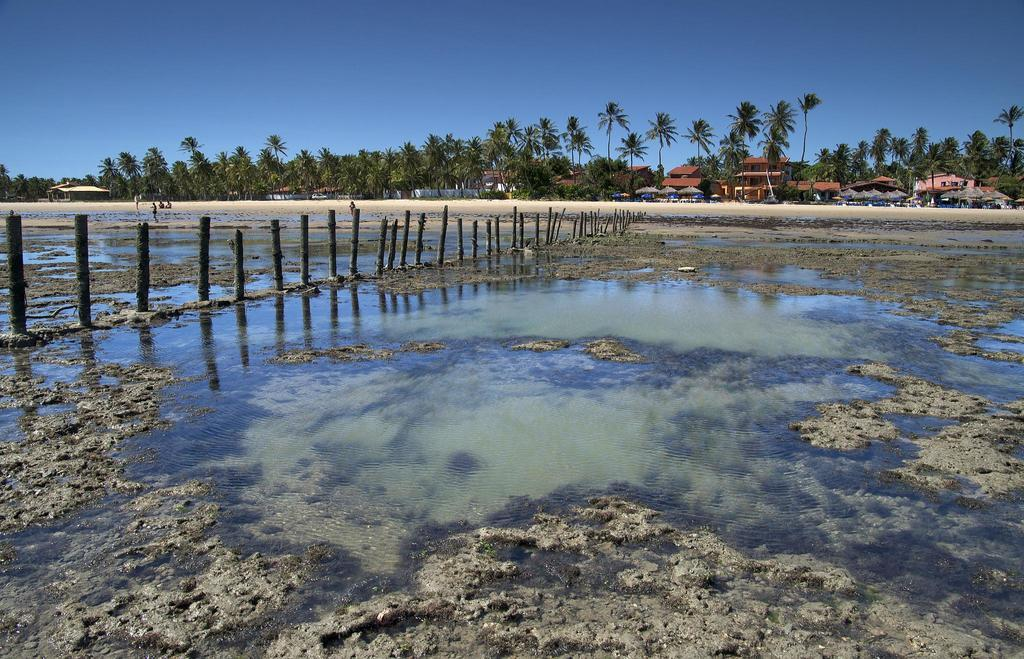What is located in the center of the image? There is water, poles, and mud in the center of the image. What can be seen in the background of the image? The sky, trees, buildings, and people can be seen in the background of the image. Where is the cobweb located in the image? There is no cobweb present in the image. What type of body is visible in the image? There is no body present in the image. 